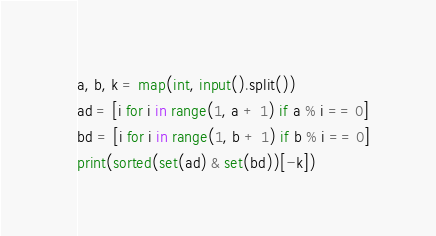Convert code to text. <code><loc_0><loc_0><loc_500><loc_500><_Python_>a, b, k = map(int, input().split())
ad = [i for i in range(1, a + 1) if a % i == 0]
bd = [i for i in range(1, b + 1) if b % i == 0]
print(sorted(set(ad) & set(bd))[-k])
</code> 